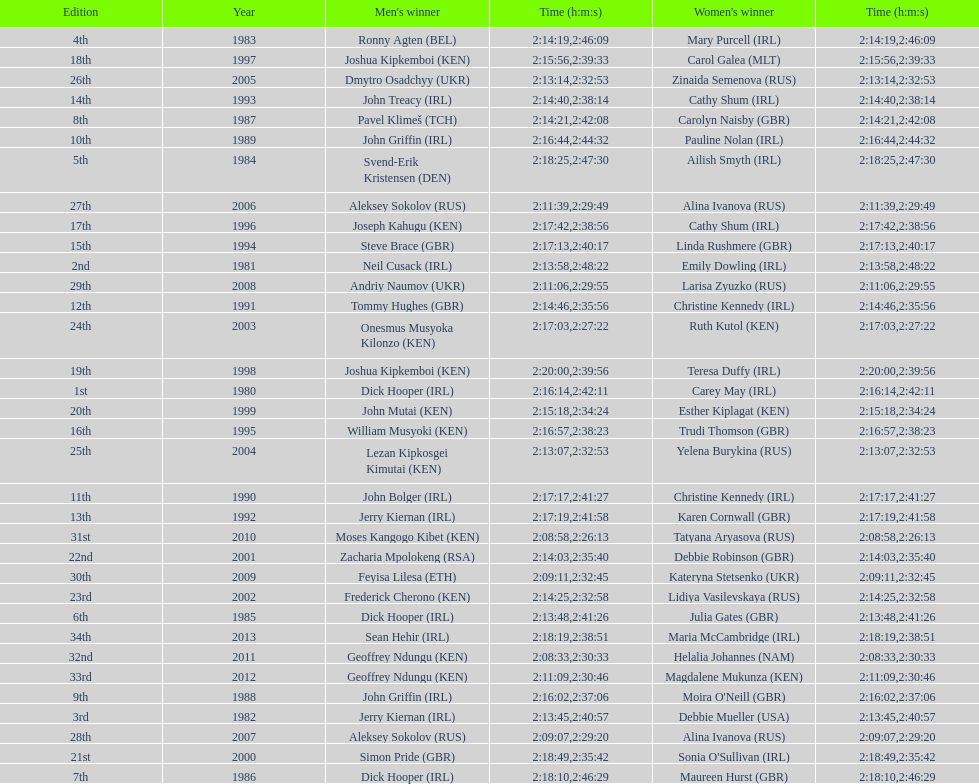In 2009, which competitor finished faster - the male or the female? Male. 